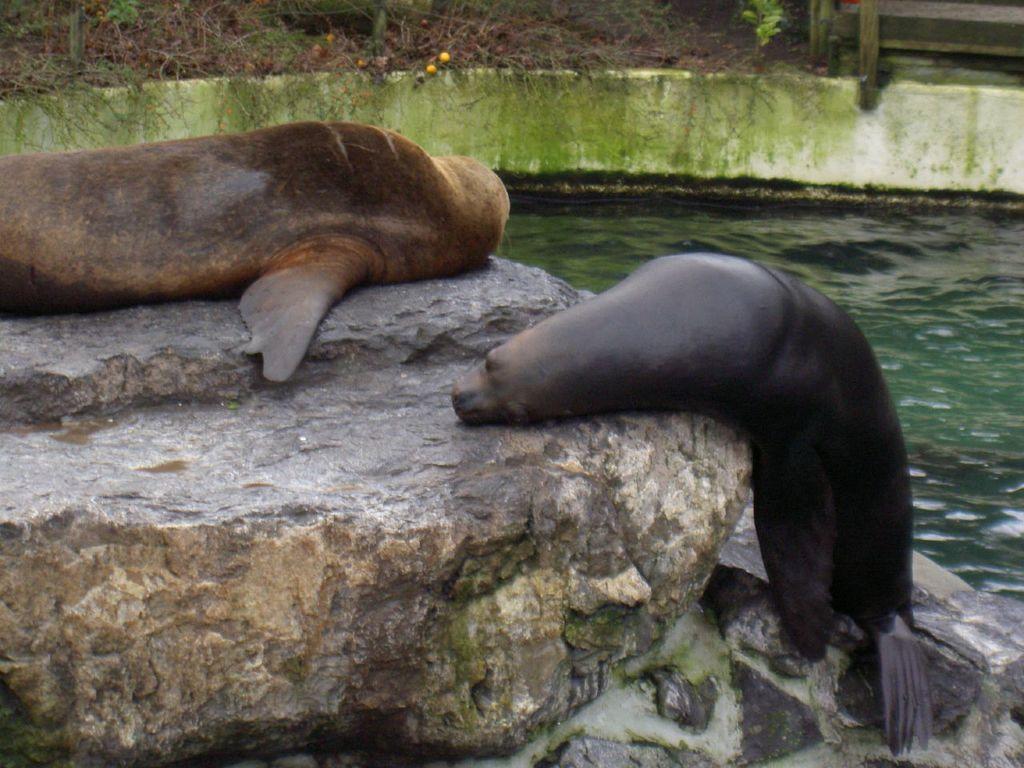Could you give a brief overview of what you see in this image? In this image we can see two sea lions lying on the rock. Here we can see the water on the right side. 